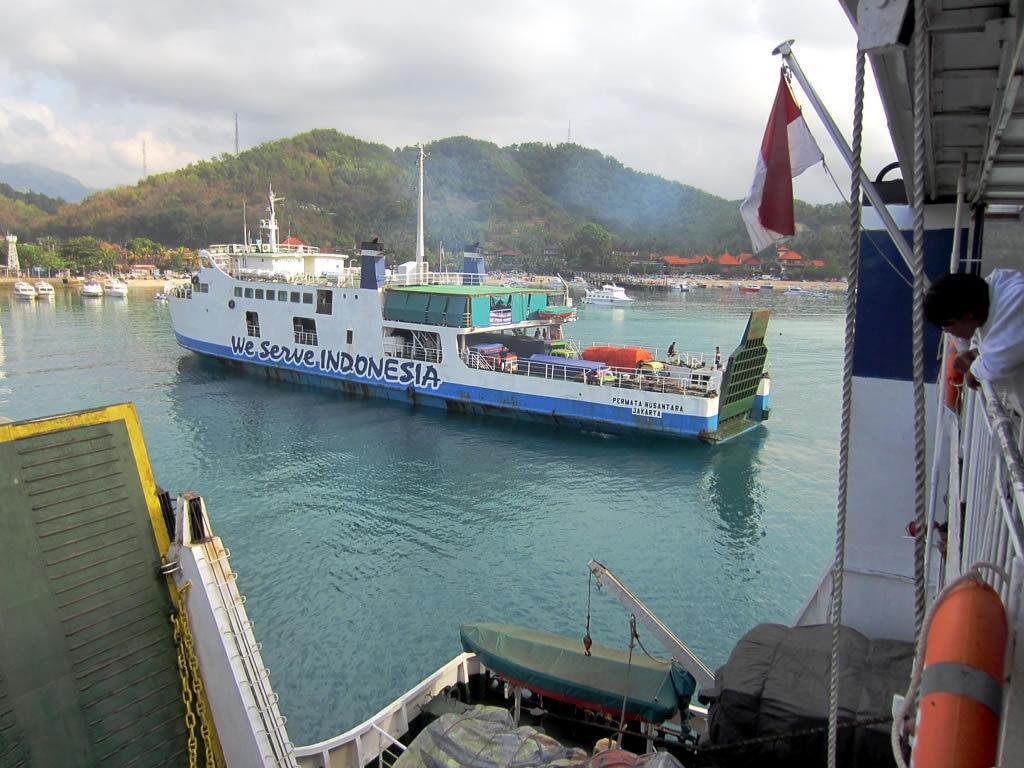Please provide a concise description of this image. In this image there are ships in the water. On the right side of the image there is a person standing on the ship. There is a flag. In the background of image there are buildings, trees, towers, mountains and sky. 